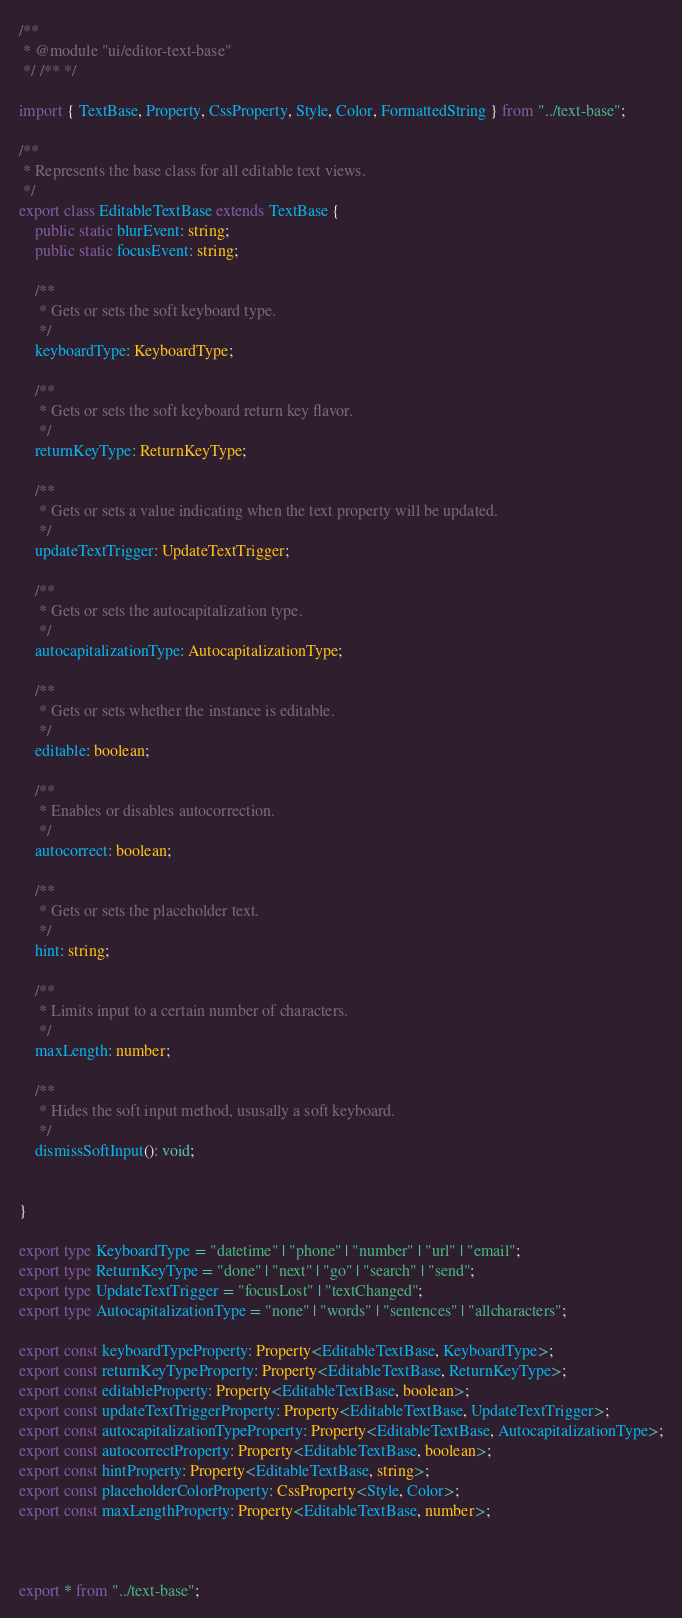Convert code to text. <code><loc_0><loc_0><loc_500><loc_500><_TypeScript_>/**
 * @module "ui/editor-text-base"
 */ /** */

import { TextBase, Property, CssProperty, Style, Color, FormattedString } from "../text-base";

/**
 * Represents the base class for all editable text views.
 */
export class EditableTextBase extends TextBase {
    public static blurEvent: string;
    public static focusEvent: string;

    /**
     * Gets or sets the soft keyboard type.
     */
    keyboardType: KeyboardType;

    /**
     * Gets or sets the soft keyboard return key flavor.
     */
    returnKeyType: ReturnKeyType;

    /**
     * Gets or sets a value indicating when the text property will be updated. 
     */
    updateTextTrigger: UpdateTextTrigger;

    /**
     * Gets or sets the autocapitalization type.
     */
    autocapitalizationType: AutocapitalizationType;

    /**
     * Gets or sets whether the instance is editable.
     */
    editable: boolean;

    /**
     * Enables or disables autocorrection.
     */
    autocorrect: boolean;

    /**
     * Gets or sets the placeholder text.
     */
    hint: string;

    /**
     * Limits input to a certain number of characters.
     */
    maxLength: number;

    /**
     * Hides the soft input method, ususally a soft keyboard.
     */
    dismissSoftInput(): void;

    
}

export type KeyboardType = "datetime" | "phone" | "number" | "url" | "email";
export type ReturnKeyType = "done" | "next" | "go" | "search" | "send";
export type UpdateTextTrigger = "focusLost" | "textChanged";
export type AutocapitalizationType = "none" | "words" | "sentences" | "allcharacters";

export const keyboardTypeProperty: Property<EditableTextBase, KeyboardType>;
export const returnKeyTypeProperty: Property<EditableTextBase, ReturnKeyType>;
export const editableProperty: Property<EditableTextBase, boolean>;
export const updateTextTriggerProperty: Property<EditableTextBase, UpdateTextTrigger>;
export const autocapitalizationTypeProperty: Property<EditableTextBase, AutocapitalizationType>;
export const autocorrectProperty: Property<EditableTextBase, boolean>;
export const hintProperty: Property<EditableTextBase, string>;
export const placeholderColorProperty: CssProperty<Style, Color>;
export const maxLengthProperty: Property<EditableTextBase, number>;



export * from "../text-base";</code> 